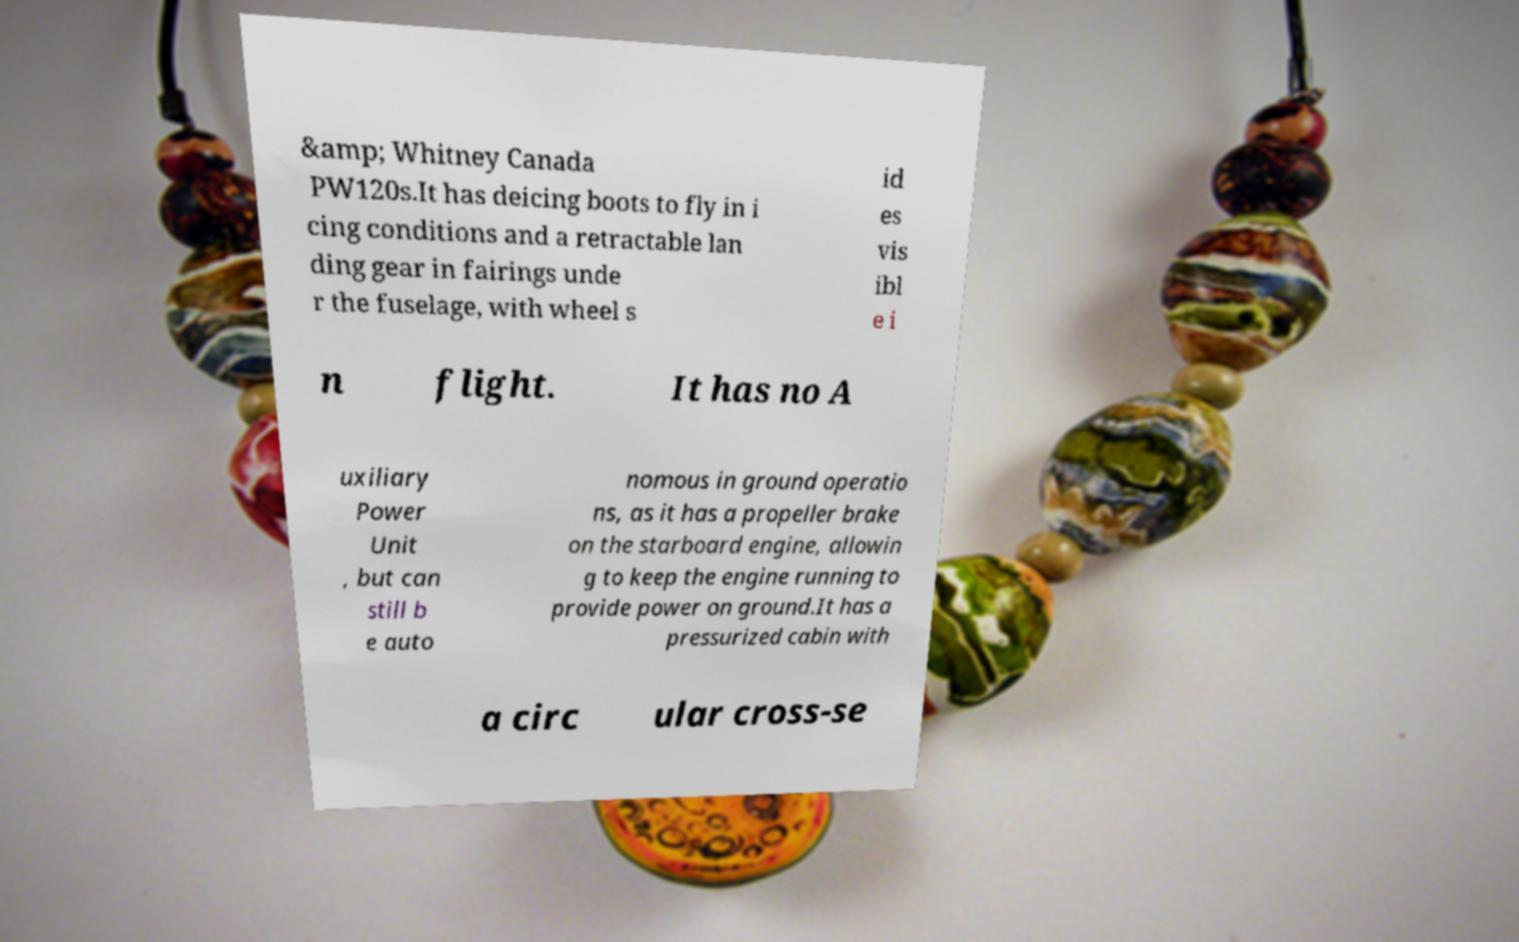Could you extract and type out the text from this image? &amp; Whitney Canada PW120s.It has deicing boots to fly in i cing conditions and a retractable lan ding gear in fairings unde r the fuselage, with wheel s id es vis ibl e i n flight. It has no A uxiliary Power Unit , but can still b e auto nomous in ground operatio ns, as it has a propeller brake on the starboard engine, allowin g to keep the engine running to provide power on ground.It has a pressurized cabin with a circ ular cross-se 